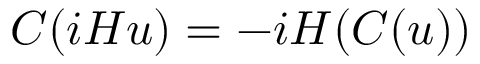Convert formula to latex. <formula><loc_0><loc_0><loc_500><loc_500>C ( i H u ) = - i H ( C ( u ) )</formula> 